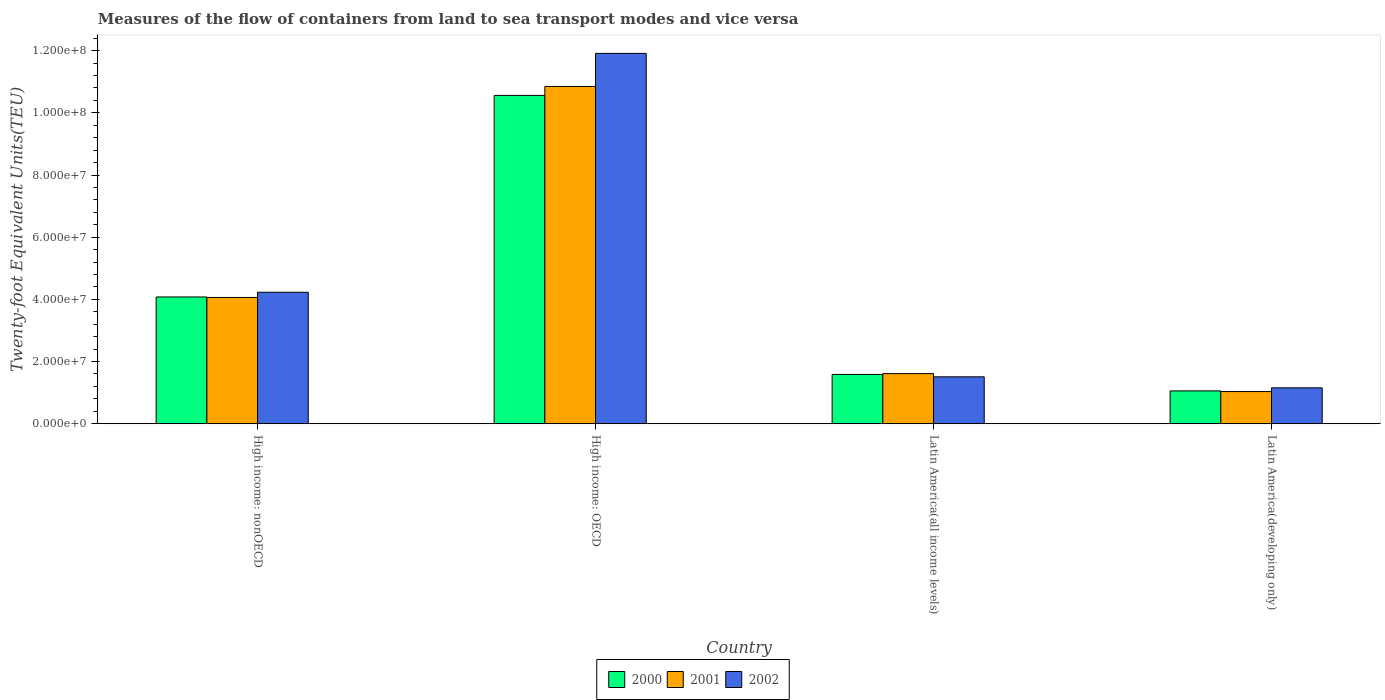How many groups of bars are there?
Your response must be concise. 4. Are the number of bars per tick equal to the number of legend labels?
Offer a very short reply. Yes. Are the number of bars on each tick of the X-axis equal?
Offer a very short reply. Yes. How many bars are there on the 2nd tick from the left?
Give a very brief answer. 3. What is the label of the 3rd group of bars from the left?
Provide a succinct answer. Latin America(all income levels). In how many cases, is the number of bars for a given country not equal to the number of legend labels?
Provide a succinct answer. 0. What is the container port traffic in 2001 in High income: OECD?
Give a very brief answer. 1.08e+08. Across all countries, what is the maximum container port traffic in 2002?
Give a very brief answer. 1.19e+08. Across all countries, what is the minimum container port traffic in 2000?
Your response must be concise. 1.06e+07. In which country was the container port traffic in 2000 maximum?
Offer a terse response. High income: OECD. In which country was the container port traffic in 2002 minimum?
Your answer should be very brief. Latin America(developing only). What is the total container port traffic in 2000 in the graph?
Keep it short and to the point. 1.73e+08. What is the difference between the container port traffic in 2001 in High income: OECD and that in Latin America(developing only)?
Provide a short and direct response. 9.81e+07. What is the difference between the container port traffic in 2000 in Latin America(all income levels) and the container port traffic in 2001 in High income: OECD?
Your response must be concise. -9.26e+07. What is the average container port traffic in 2001 per country?
Ensure brevity in your answer.  4.39e+07. What is the difference between the container port traffic of/in 2002 and container port traffic of/in 2001 in Latin America(all income levels)?
Keep it short and to the point. -1.04e+06. In how many countries, is the container port traffic in 2000 greater than 84000000 TEU?
Make the answer very short. 1. What is the ratio of the container port traffic in 2002 in High income: nonOECD to that in Latin America(developing only)?
Your response must be concise. 3.66. Is the difference between the container port traffic in 2002 in High income: OECD and High income: nonOECD greater than the difference between the container port traffic in 2001 in High income: OECD and High income: nonOECD?
Keep it short and to the point. Yes. What is the difference between the highest and the second highest container port traffic in 2000?
Provide a succinct answer. 6.48e+07. What is the difference between the highest and the lowest container port traffic in 2001?
Your response must be concise. 9.81e+07. Is it the case that in every country, the sum of the container port traffic in 2000 and container port traffic in 2002 is greater than the container port traffic in 2001?
Give a very brief answer. Yes. How many countries are there in the graph?
Keep it short and to the point. 4. Are the values on the major ticks of Y-axis written in scientific E-notation?
Make the answer very short. Yes. Does the graph contain any zero values?
Make the answer very short. No. Does the graph contain grids?
Your response must be concise. No. How many legend labels are there?
Your answer should be compact. 3. What is the title of the graph?
Give a very brief answer. Measures of the flow of containers from land to sea transport modes and vice versa. Does "2004" appear as one of the legend labels in the graph?
Give a very brief answer. No. What is the label or title of the X-axis?
Offer a terse response. Country. What is the label or title of the Y-axis?
Give a very brief answer. Twenty-foot Equivalent Units(TEU). What is the Twenty-foot Equivalent Units(TEU) of 2000 in High income: nonOECD?
Give a very brief answer. 4.08e+07. What is the Twenty-foot Equivalent Units(TEU) in 2001 in High income: nonOECD?
Provide a succinct answer. 4.06e+07. What is the Twenty-foot Equivalent Units(TEU) in 2002 in High income: nonOECD?
Provide a short and direct response. 4.23e+07. What is the Twenty-foot Equivalent Units(TEU) of 2000 in High income: OECD?
Your answer should be compact. 1.06e+08. What is the Twenty-foot Equivalent Units(TEU) in 2001 in High income: OECD?
Give a very brief answer. 1.08e+08. What is the Twenty-foot Equivalent Units(TEU) in 2002 in High income: OECD?
Your response must be concise. 1.19e+08. What is the Twenty-foot Equivalent Units(TEU) of 2000 in Latin America(all income levels)?
Your answer should be compact. 1.59e+07. What is the Twenty-foot Equivalent Units(TEU) in 2001 in Latin America(all income levels)?
Give a very brief answer. 1.61e+07. What is the Twenty-foot Equivalent Units(TEU) in 2002 in Latin America(all income levels)?
Offer a terse response. 1.51e+07. What is the Twenty-foot Equivalent Units(TEU) in 2000 in Latin America(developing only)?
Offer a terse response. 1.06e+07. What is the Twenty-foot Equivalent Units(TEU) in 2001 in Latin America(developing only)?
Give a very brief answer. 1.04e+07. What is the Twenty-foot Equivalent Units(TEU) of 2002 in Latin America(developing only)?
Provide a succinct answer. 1.16e+07. Across all countries, what is the maximum Twenty-foot Equivalent Units(TEU) in 2000?
Keep it short and to the point. 1.06e+08. Across all countries, what is the maximum Twenty-foot Equivalent Units(TEU) in 2001?
Your answer should be very brief. 1.08e+08. Across all countries, what is the maximum Twenty-foot Equivalent Units(TEU) of 2002?
Give a very brief answer. 1.19e+08. Across all countries, what is the minimum Twenty-foot Equivalent Units(TEU) in 2000?
Provide a short and direct response. 1.06e+07. Across all countries, what is the minimum Twenty-foot Equivalent Units(TEU) in 2001?
Provide a short and direct response. 1.04e+07. Across all countries, what is the minimum Twenty-foot Equivalent Units(TEU) in 2002?
Make the answer very short. 1.16e+07. What is the total Twenty-foot Equivalent Units(TEU) of 2000 in the graph?
Your response must be concise. 1.73e+08. What is the total Twenty-foot Equivalent Units(TEU) in 2001 in the graph?
Your answer should be compact. 1.76e+08. What is the total Twenty-foot Equivalent Units(TEU) in 2002 in the graph?
Your answer should be very brief. 1.88e+08. What is the difference between the Twenty-foot Equivalent Units(TEU) of 2000 in High income: nonOECD and that in High income: OECD?
Ensure brevity in your answer.  -6.48e+07. What is the difference between the Twenty-foot Equivalent Units(TEU) in 2001 in High income: nonOECD and that in High income: OECD?
Make the answer very short. -6.79e+07. What is the difference between the Twenty-foot Equivalent Units(TEU) in 2002 in High income: nonOECD and that in High income: OECD?
Give a very brief answer. -7.68e+07. What is the difference between the Twenty-foot Equivalent Units(TEU) of 2000 in High income: nonOECD and that in Latin America(all income levels)?
Keep it short and to the point. 2.49e+07. What is the difference between the Twenty-foot Equivalent Units(TEU) of 2001 in High income: nonOECD and that in Latin America(all income levels)?
Keep it short and to the point. 2.45e+07. What is the difference between the Twenty-foot Equivalent Units(TEU) in 2002 in High income: nonOECD and that in Latin America(all income levels)?
Provide a succinct answer. 2.72e+07. What is the difference between the Twenty-foot Equivalent Units(TEU) of 2000 in High income: nonOECD and that in Latin America(developing only)?
Provide a succinct answer. 3.02e+07. What is the difference between the Twenty-foot Equivalent Units(TEU) in 2001 in High income: nonOECD and that in Latin America(developing only)?
Your answer should be very brief. 3.03e+07. What is the difference between the Twenty-foot Equivalent Units(TEU) of 2002 in High income: nonOECD and that in Latin America(developing only)?
Your response must be concise. 3.07e+07. What is the difference between the Twenty-foot Equivalent Units(TEU) of 2000 in High income: OECD and that in Latin America(all income levels)?
Keep it short and to the point. 8.98e+07. What is the difference between the Twenty-foot Equivalent Units(TEU) of 2001 in High income: OECD and that in Latin America(all income levels)?
Offer a very short reply. 9.24e+07. What is the difference between the Twenty-foot Equivalent Units(TEU) in 2002 in High income: OECD and that in Latin America(all income levels)?
Offer a terse response. 1.04e+08. What is the difference between the Twenty-foot Equivalent Units(TEU) of 2000 in High income: OECD and that in Latin America(developing only)?
Provide a short and direct response. 9.51e+07. What is the difference between the Twenty-foot Equivalent Units(TEU) in 2001 in High income: OECD and that in Latin America(developing only)?
Your response must be concise. 9.81e+07. What is the difference between the Twenty-foot Equivalent Units(TEU) in 2002 in High income: OECD and that in Latin America(developing only)?
Provide a short and direct response. 1.08e+08. What is the difference between the Twenty-foot Equivalent Units(TEU) of 2000 in Latin America(all income levels) and that in Latin America(developing only)?
Your answer should be compact. 5.30e+06. What is the difference between the Twenty-foot Equivalent Units(TEU) in 2001 in Latin America(all income levels) and that in Latin America(developing only)?
Your answer should be compact. 5.78e+06. What is the difference between the Twenty-foot Equivalent Units(TEU) of 2002 in Latin America(all income levels) and that in Latin America(developing only)?
Make the answer very short. 3.53e+06. What is the difference between the Twenty-foot Equivalent Units(TEU) of 2000 in High income: nonOECD and the Twenty-foot Equivalent Units(TEU) of 2001 in High income: OECD?
Give a very brief answer. -6.77e+07. What is the difference between the Twenty-foot Equivalent Units(TEU) in 2000 in High income: nonOECD and the Twenty-foot Equivalent Units(TEU) in 2002 in High income: OECD?
Ensure brevity in your answer.  -7.83e+07. What is the difference between the Twenty-foot Equivalent Units(TEU) in 2001 in High income: nonOECD and the Twenty-foot Equivalent Units(TEU) in 2002 in High income: OECD?
Offer a terse response. -7.85e+07. What is the difference between the Twenty-foot Equivalent Units(TEU) of 2000 in High income: nonOECD and the Twenty-foot Equivalent Units(TEU) of 2001 in Latin America(all income levels)?
Provide a succinct answer. 2.47e+07. What is the difference between the Twenty-foot Equivalent Units(TEU) of 2000 in High income: nonOECD and the Twenty-foot Equivalent Units(TEU) of 2002 in Latin America(all income levels)?
Your response must be concise. 2.57e+07. What is the difference between the Twenty-foot Equivalent Units(TEU) in 2001 in High income: nonOECD and the Twenty-foot Equivalent Units(TEU) in 2002 in Latin America(all income levels)?
Ensure brevity in your answer.  2.55e+07. What is the difference between the Twenty-foot Equivalent Units(TEU) in 2000 in High income: nonOECD and the Twenty-foot Equivalent Units(TEU) in 2001 in Latin America(developing only)?
Provide a short and direct response. 3.04e+07. What is the difference between the Twenty-foot Equivalent Units(TEU) of 2000 in High income: nonOECD and the Twenty-foot Equivalent Units(TEU) of 2002 in Latin America(developing only)?
Make the answer very short. 2.92e+07. What is the difference between the Twenty-foot Equivalent Units(TEU) of 2001 in High income: nonOECD and the Twenty-foot Equivalent Units(TEU) of 2002 in Latin America(developing only)?
Provide a short and direct response. 2.91e+07. What is the difference between the Twenty-foot Equivalent Units(TEU) of 2000 in High income: OECD and the Twenty-foot Equivalent Units(TEU) of 2001 in Latin America(all income levels)?
Your answer should be compact. 8.95e+07. What is the difference between the Twenty-foot Equivalent Units(TEU) of 2000 in High income: OECD and the Twenty-foot Equivalent Units(TEU) of 2002 in Latin America(all income levels)?
Offer a terse response. 9.05e+07. What is the difference between the Twenty-foot Equivalent Units(TEU) in 2001 in High income: OECD and the Twenty-foot Equivalent Units(TEU) in 2002 in Latin America(all income levels)?
Your answer should be compact. 9.34e+07. What is the difference between the Twenty-foot Equivalent Units(TEU) in 2000 in High income: OECD and the Twenty-foot Equivalent Units(TEU) in 2001 in Latin America(developing only)?
Your answer should be compact. 9.53e+07. What is the difference between the Twenty-foot Equivalent Units(TEU) of 2000 in High income: OECD and the Twenty-foot Equivalent Units(TEU) of 2002 in Latin America(developing only)?
Your answer should be compact. 9.41e+07. What is the difference between the Twenty-foot Equivalent Units(TEU) of 2001 in High income: OECD and the Twenty-foot Equivalent Units(TEU) of 2002 in Latin America(developing only)?
Provide a succinct answer. 9.69e+07. What is the difference between the Twenty-foot Equivalent Units(TEU) in 2000 in Latin America(all income levels) and the Twenty-foot Equivalent Units(TEU) in 2001 in Latin America(developing only)?
Your answer should be compact. 5.51e+06. What is the difference between the Twenty-foot Equivalent Units(TEU) in 2000 in Latin America(all income levels) and the Twenty-foot Equivalent Units(TEU) in 2002 in Latin America(developing only)?
Make the answer very short. 4.30e+06. What is the difference between the Twenty-foot Equivalent Units(TEU) in 2001 in Latin America(all income levels) and the Twenty-foot Equivalent Units(TEU) in 2002 in Latin America(developing only)?
Ensure brevity in your answer.  4.57e+06. What is the average Twenty-foot Equivalent Units(TEU) in 2000 per country?
Your answer should be compact. 4.32e+07. What is the average Twenty-foot Equivalent Units(TEU) of 2001 per country?
Provide a succinct answer. 4.39e+07. What is the average Twenty-foot Equivalent Units(TEU) in 2002 per country?
Your response must be concise. 4.70e+07. What is the difference between the Twenty-foot Equivalent Units(TEU) of 2000 and Twenty-foot Equivalent Units(TEU) of 2001 in High income: nonOECD?
Give a very brief answer. 1.60e+05. What is the difference between the Twenty-foot Equivalent Units(TEU) in 2000 and Twenty-foot Equivalent Units(TEU) in 2002 in High income: nonOECD?
Offer a terse response. -1.51e+06. What is the difference between the Twenty-foot Equivalent Units(TEU) of 2001 and Twenty-foot Equivalent Units(TEU) of 2002 in High income: nonOECD?
Make the answer very short. -1.67e+06. What is the difference between the Twenty-foot Equivalent Units(TEU) of 2000 and Twenty-foot Equivalent Units(TEU) of 2001 in High income: OECD?
Your answer should be compact. -2.88e+06. What is the difference between the Twenty-foot Equivalent Units(TEU) in 2000 and Twenty-foot Equivalent Units(TEU) in 2002 in High income: OECD?
Keep it short and to the point. -1.35e+07. What is the difference between the Twenty-foot Equivalent Units(TEU) of 2001 and Twenty-foot Equivalent Units(TEU) of 2002 in High income: OECD?
Your answer should be very brief. -1.06e+07. What is the difference between the Twenty-foot Equivalent Units(TEU) of 2000 and Twenty-foot Equivalent Units(TEU) of 2001 in Latin America(all income levels)?
Offer a very short reply. -2.69e+05. What is the difference between the Twenty-foot Equivalent Units(TEU) of 2000 and Twenty-foot Equivalent Units(TEU) of 2002 in Latin America(all income levels)?
Make the answer very short. 7.70e+05. What is the difference between the Twenty-foot Equivalent Units(TEU) of 2001 and Twenty-foot Equivalent Units(TEU) of 2002 in Latin America(all income levels)?
Give a very brief answer. 1.04e+06. What is the difference between the Twenty-foot Equivalent Units(TEU) in 2000 and Twenty-foot Equivalent Units(TEU) in 2001 in Latin America(developing only)?
Provide a short and direct response. 2.09e+05. What is the difference between the Twenty-foot Equivalent Units(TEU) in 2000 and Twenty-foot Equivalent Units(TEU) in 2002 in Latin America(developing only)?
Provide a succinct answer. -9.97e+05. What is the difference between the Twenty-foot Equivalent Units(TEU) of 2001 and Twenty-foot Equivalent Units(TEU) of 2002 in Latin America(developing only)?
Your response must be concise. -1.21e+06. What is the ratio of the Twenty-foot Equivalent Units(TEU) in 2000 in High income: nonOECD to that in High income: OECD?
Your response must be concise. 0.39. What is the ratio of the Twenty-foot Equivalent Units(TEU) of 2001 in High income: nonOECD to that in High income: OECD?
Your response must be concise. 0.37. What is the ratio of the Twenty-foot Equivalent Units(TEU) of 2002 in High income: nonOECD to that in High income: OECD?
Your answer should be compact. 0.35. What is the ratio of the Twenty-foot Equivalent Units(TEU) of 2000 in High income: nonOECD to that in Latin America(all income levels)?
Your answer should be very brief. 2.57. What is the ratio of the Twenty-foot Equivalent Units(TEU) in 2001 in High income: nonOECD to that in Latin America(all income levels)?
Give a very brief answer. 2.52. What is the ratio of the Twenty-foot Equivalent Units(TEU) of 2002 in High income: nonOECD to that in Latin America(all income levels)?
Provide a short and direct response. 2.8. What is the ratio of the Twenty-foot Equivalent Units(TEU) of 2000 in High income: nonOECD to that in Latin America(developing only)?
Provide a short and direct response. 3.86. What is the ratio of the Twenty-foot Equivalent Units(TEU) of 2001 in High income: nonOECD to that in Latin America(developing only)?
Offer a terse response. 3.92. What is the ratio of the Twenty-foot Equivalent Units(TEU) of 2002 in High income: nonOECD to that in Latin America(developing only)?
Offer a terse response. 3.66. What is the ratio of the Twenty-foot Equivalent Units(TEU) in 2000 in High income: OECD to that in Latin America(all income levels)?
Your answer should be compact. 6.66. What is the ratio of the Twenty-foot Equivalent Units(TEU) in 2001 in High income: OECD to that in Latin America(all income levels)?
Your response must be concise. 6.73. What is the ratio of the Twenty-foot Equivalent Units(TEU) of 2002 in High income: OECD to that in Latin America(all income levels)?
Your answer should be compact. 7.89. What is the ratio of the Twenty-foot Equivalent Units(TEU) in 2000 in High income: OECD to that in Latin America(developing only)?
Your response must be concise. 10. What is the ratio of the Twenty-foot Equivalent Units(TEU) of 2001 in High income: OECD to that in Latin America(developing only)?
Ensure brevity in your answer.  10.48. What is the ratio of the Twenty-foot Equivalent Units(TEU) in 2002 in High income: OECD to that in Latin America(developing only)?
Provide a short and direct response. 10.31. What is the ratio of the Twenty-foot Equivalent Units(TEU) in 2000 in Latin America(all income levels) to that in Latin America(developing only)?
Ensure brevity in your answer.  1.5. What is the ratio of the Twenty-foot Equivalent Units(TEU) in 2001 in Latin America(all income levels) to that in Latin America(developing only)?
Your answer should be compact. 1.56. What is the ratio of the Twenty-foot Equivalent Units(TEU) of 2002 in Latin America(all income levels) to that in Latin America(developing only)?
Provide a succinct answer. 1.31. What is the difference between the highest and the second highest Twenty-foot Equivalent Units(TEU) in 2000?
Your answer should be compact. 6.48e+07. What is the difference between the highest and the second highest Twenty-foot Equivalent Units(TEU) in 2001?
Give a very brief answer. 6.79e+07. What is the difference between the highest and the second highest Twenty-foot Equivalent Units(TEU) of 2002?
Offer a terse response. 7.68e+07. What is the difference between the highest and the lowest Twenty-foot Equivalent Units(TEU) in 2000?
Make the answer very short. 9.51e+07. What is the difference between the highest and the lowest Twenty-foot Equivalent Units(TEU) in 2001?
Provide a short and direct response. 9.81e+07. What is the difference between the highest and the lowest Twenty-foot Equivalent Units(TEU) of 2002?
Provide a succinct answer. 1.08e+08. 